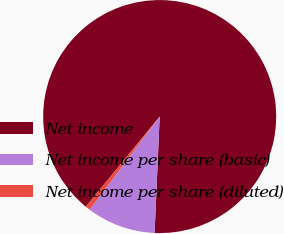Convert chart. <chart><loc_0><loc_0><loc_500><loc_500><pie_chart><fcel>Net income<fcel>Net income per share (basic)<fcel>Net income per share (diluted)<nl><fcel>89.77%<fcel>9.57%<fcel>0.66%<nl></chart> 